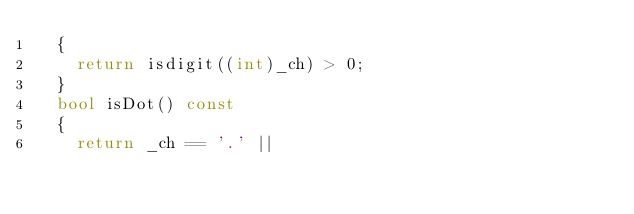<code> <loc_0><loc_0><loc_500><loc_500><_C++_>	{
		return isdigit((int)_ch) > 0;
	}
	bool isDot() const
	{
		return _ch == '.' ||</code> 